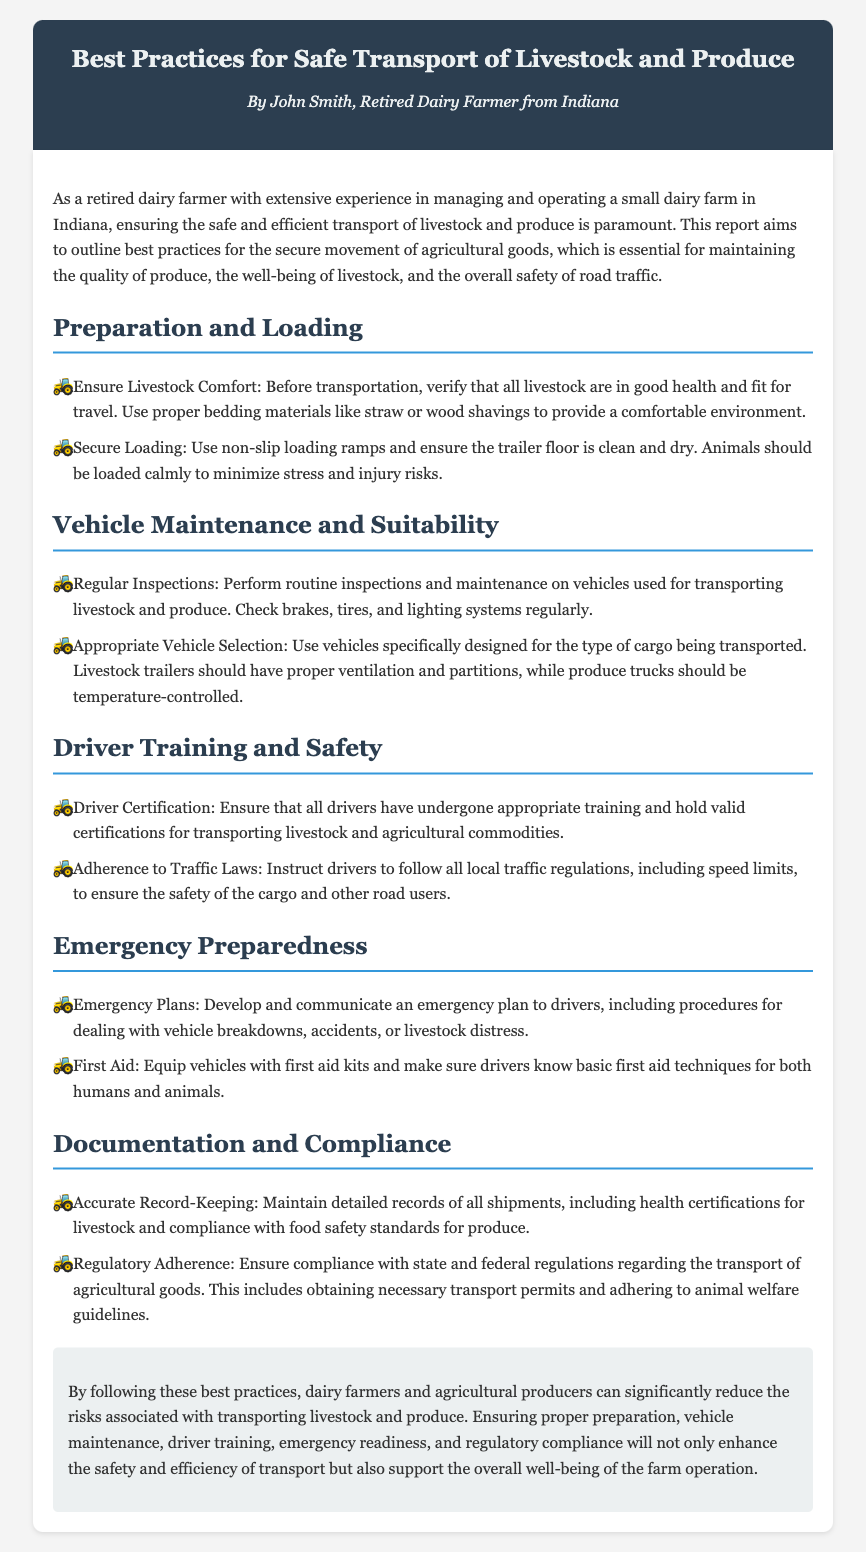What is the author's profession? The author identifies as a retired dairy farmer based on the introduction of the document.
Answer: Retired dairy farmer What does the document analyze? The document analyzes best practices for the safe transport of livestock and produce.
Answer: Best practices for safe transport What should be used for livestock comfort? The document states that proper bedding materials like straw or wood shavings should be used.
Answer: Straw or wood shavings What is required for driver safety training? According to the document, all drivers must have undergone appropriate training and hold valid certifications.
Answer: Valid certifications What does the emergency plan include? The document mentions procedures for dealing with vehicle breakdowns and accidents in the emergency plan.
Answer: Breakdown procedures What vehicle aspect should be checked regularly? The document emphasizes the importance of performing routine inspections on brakes, tires, and lighting systems.
Answer: Brakes How often should vehicle maintenance be performed? The document implies that routine inspections should occur regularly, but does not specify exact timing.
Answer: Regularly What should vehicles transporting produce have? The document specifies that produce trucks should have temperature control to maintain quality.
Answer: Temperature control What type of records should be kept? The document advises maintaining detailed records of all shipments, including health certifications.
Answer: Shipment records 